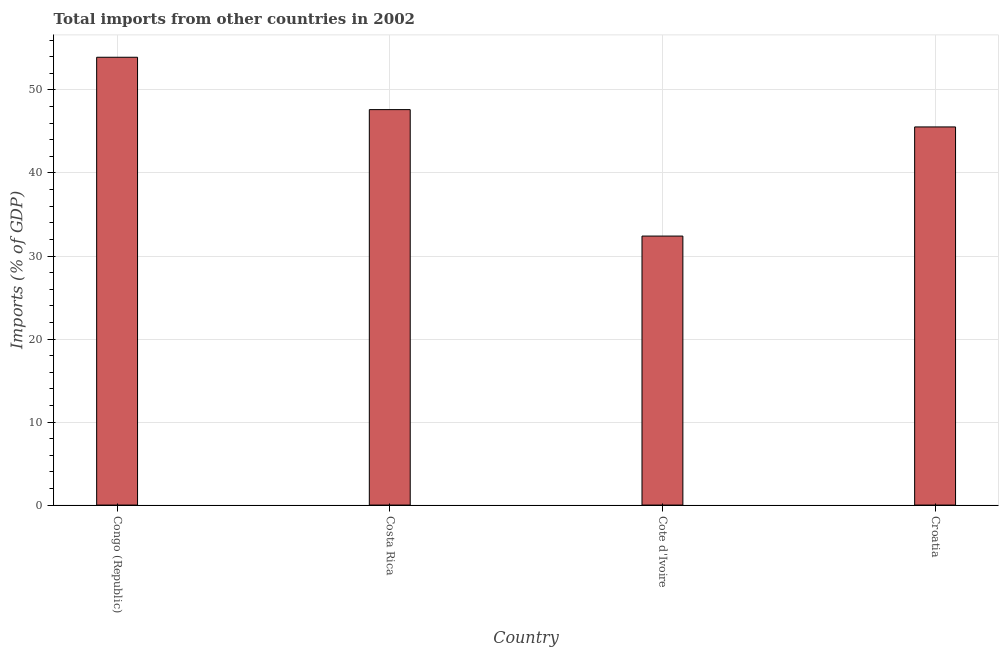What is the title of the graph?
Ensure brevity in your answer.  Total imports from other countries in 2002. What is the label or title of the Y-axis?
Offer a very short reply. Imports (% of GDP). What is the total imports in Congo (Republic)?
Give a very brief answer. 53.94. Across all countries, what is the maximum total imports?
Make the answer very short. 53.94. Across all countries, what is the minimum total imports?
Your response must be concise. 32.4. In which country was the total imports maximum?
Keep it short and to the point. Congo (Republic). In which country was the total imports minimum?
Keep it short and to the point. Cote d'Ivoire. What is the sum of the total imports?
Provide a succinct answer. 179.52. What is the difference between the total imports in Costa Rica and Croatia?
Provide a succinct answer. 2.09. What is the average total imports per country?
Ensure brevity in your answer.  44.88. What is the median total imports?
Offer a very short reply. 46.59. In how many countries, is the total imports greater than 12 %?
Give a very brief answer. 4. What is the ratio of the total imports in Congo (Republic) to that in Croatia?
Provide a short and direct response. 1.18. What is the difference between the highest and the second highest total imports?
Your answer should be compact. 6.31. Is the sum of the total imports in Congo (Republic) and Costa Rica greater than the maximum total imports across all countries?
Your response must be concise. Yes. What is the difference between the highest and the lowest total imports?
Your answer should be compact. 21.54. In how many countries, is the total imports greater than the average total imports taken over all countries?
Your answer should be compact. 3. How many bars are there?
Keep it short and to the point. 4. What is the Imports (% of GDP) of Congo (Republic)?
Make the answer very short. 53.94. What is the Imports (% of GDP) of Costa Rica?
Offer a very short reply. 47.63. What is the Imports (% of GDP) of Cote d'Ivoire?
Ensure brevity in your answer.  32.4. What is the Imports (% of GDP) in Croatia?
Offer a very short reply. 45.55. What is the difference between the Imports (% of GDP) in Congo (Republic) and Costa Rica?
Give a very brief answer. 6.31. What is the difference between the Imports (% of GDP) in Congo (Republic) and Cote d'Ivoire?
Provide a succinct answer. 21.54. What is the difference between the Imports (% of GDP) in Congo (Republic) and Croatia?
Give a very brief answer. 8.39. What is the difference between the Imports (% of GDP) in Costa Rica and Cote d'Ivoire?
Your answer should be very brief. 15.23. What is the difference between the Imports (% of GDP) in Costa Rica and Croatia?
Offer a terse response. 2.09. What is the difference between the Imports (% of GDP) in Cote d'Ivoire and Croatia?
Make the answer very short. -13.15. What is the ratio of the Imports (% of GDP) in Congo (Republic) to that in Costa Rica?
Provide a succinct answer. 1.13. What is the ratio of the Imports (% of GDP) in Congo (Republic) to that in Cote d'Ivoire?
Keep it short and to the point. 1.67. What is the ratio of the Imports (% of GDP) in Congo (Republic) to that in Croatia?
Your answer should be compact. 1.18. What is the ratio of the Imports (% of GDP) in Costa Rica to that in Cote d'Ivoire?
Offer a terse response. 1.47. What is the ratio of the Imports (% of GDP) in Costa Rica to that in Croatia?
Your answer should be compact. 1.05. What is the ratio of the Imports (% of GDP) in Cote d'Ivoire to that in Croatia?
Ensure brevity in your answer.  0.71. 